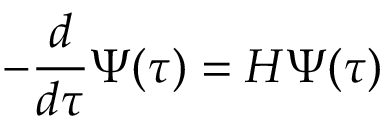Convert formula to latex. <formula><loc_0><loc_0><loc_500><loc_500>- { \frac { d } { d \tau } } \Psi ( \tau ) = H \Psi ( \tau )</formula> 